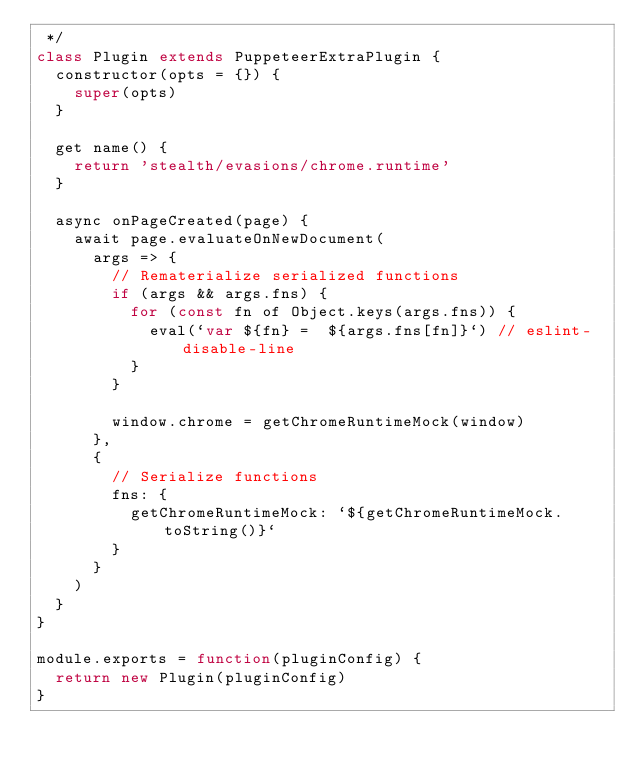<code> <loc_0><loc_0><loc_500><loc_500><_JavaScript_> */
class Plugin extends PuppeteerExtraPlugin {
  constructor(opts = {}) {
    super(opts)
  }

  get name() {
    return 'stealth/evasions/chrome.runtime'
  }

  async onPageCreated(page) {
    await page.evaluateOnNewDocument(
      args => {
        // Rematerialize serialized functions
        if (args && args.fns) {
          for (const fn of Object.keys(args.fns)) {
            eval(`var ${fn} =  ${args.fns[fn]}`) // eslint-disable-line
          }
        }

        window.chrome = getChromeRuntimeMock(window)
      },
      {
        // Serialize functions
        fns: {
          getChromeRuntimeMock: `${getChromeRuntimeMock.toString()}`
        }
      }
    )
  }
}

module.exports = function(pluginConfig) {
  return new Plugin(pluginConfig)
}
</code> 